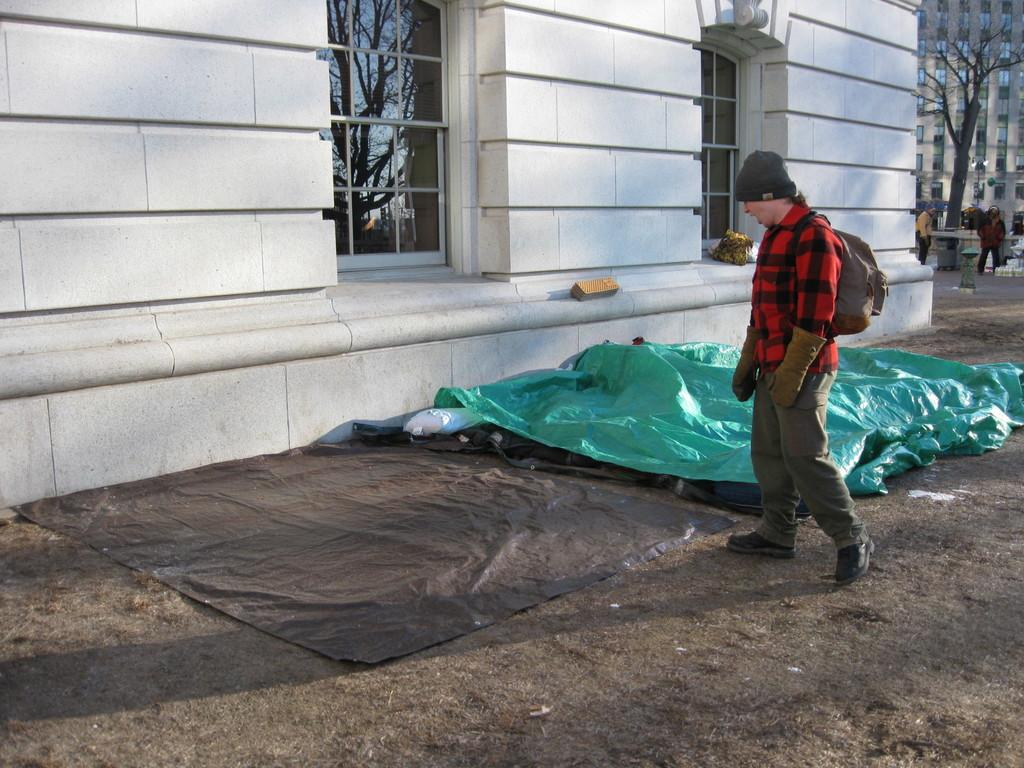What type of structures can be seen in the image? There are buildings in the image. What natural element is present in the image? There is a tree in the image. What type of fabric is visible in the image? There are sheets in the image. Can you describe the people in the image? There are people in the image. How can you tell that one person is wearing a bag and cap? One person is wearing a bag and cap in the image. What is the reflection of in the window glass in the image? There is a reflection of a tree and sky on a window glass in the image. How many plates are visible on the table in the image? There is no table or plates present in the image. What type of chairs can be seen in the image? There are no chairs present in the image. 